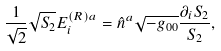<formula> <loc_0><loc_0><loc_500><loc_500>\frac { 1 } { \sqrt { 2 } } \sqrt { S _ { 2 } } E _ { i } ^ { ( R ) a } = \hat { n } ^ { a } \sqrt { - g _ { 0 0 } } \frac { \partial _ { i } S _ { 2 } } { S _ { 2 } } ,</formula> 